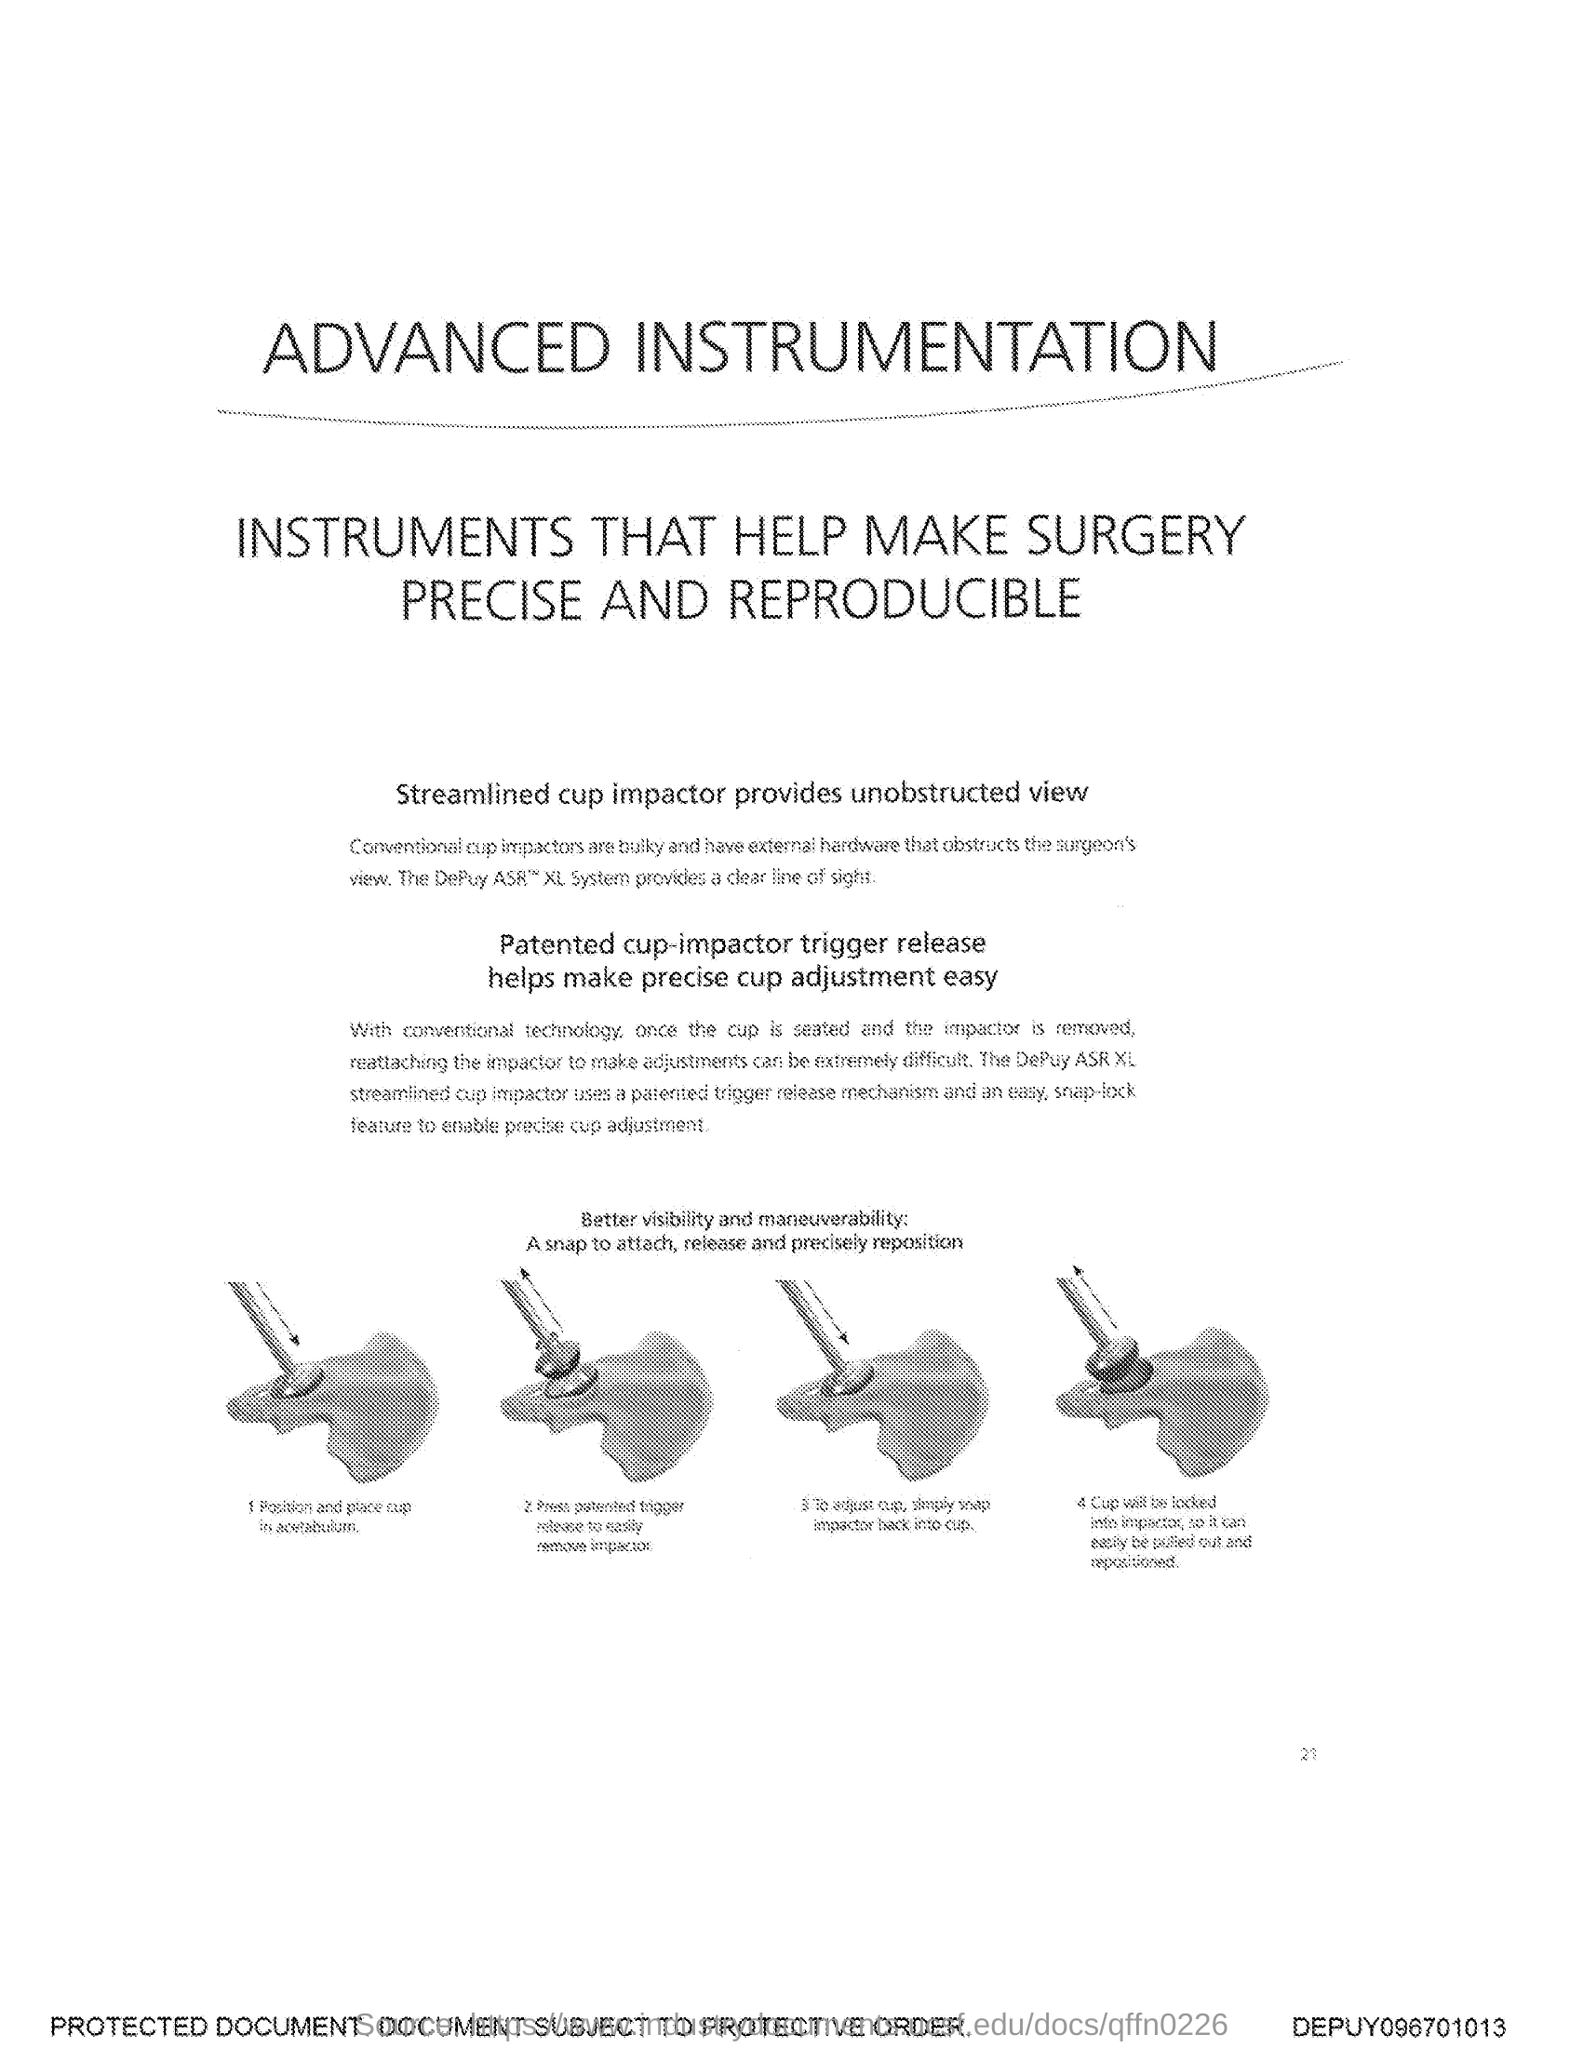What is the number at bottom of the page?
Ensure brevity in your answer.  21. 